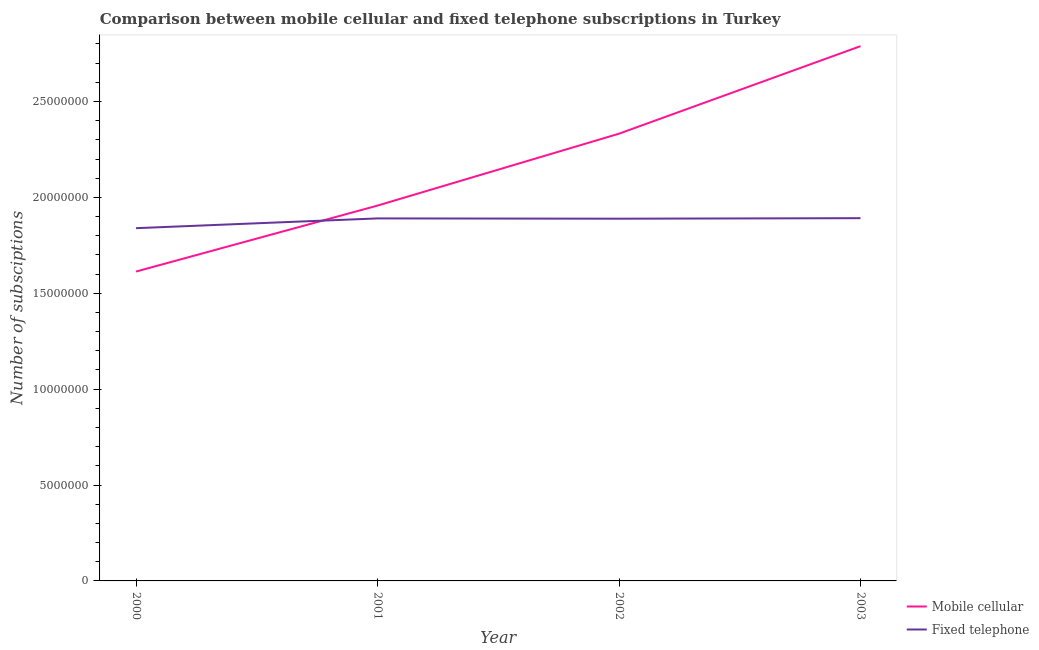How many different coloured lines are there?
Ensure brevity in your answer.  2. Does the line corresponding to number of fixed telephone subscriptions intersect with the line corresponding to number of mobile cellular subscriptions?
Keep it short and to the point. Yes. What is the number of fixed telephone subscriptions in 2000?
Provide a short and direct response. 1.84e+07. Across all years, what is the maximum number of fixed telephone subscriptions?
Keep it short and to the point. 1.89e+07. Across all years, what is the minimum number of mobile cellular subscriptions?
Provide a succinct answer. 1.61e+07. In which year was the number of mobile cellular subscriptions maximum?
Make the answer very short. 2003. In which year was the number of fixed telephone subscriptions minimum?
Provide a succinct answer. 2000. What is the total number of mobile cellular subscriptions in the graph?
Give a very brief answer. 8.69e+07. What is the difference between the number of mobile cellular subscriptions in 2000 and that in 2001?
Provide a succinct answer. -3.44e+06. What is the difference between the number of mobile cellular subscriptions in 2002 and the number of fixed telephone subscriptions in 2001?
Your answer should be very brief. 4.42e+06. What is the average number of fixed telephone subscriptions per year?
Offer a terse response. 1.88e+07. In the year 2000, what is the difference between the number of mobile cellular subscriptions and number of fixed telephone subscriptions?
Keep it short and to the point. -2.26e+06. What is the ratio of the number of mobile cellular subscriptions in 2002 to that in 2003?
Give a very brief answer. 0.84. Is the number of mobile cellular subscriptions in 2000 less than that in 2001?
Your answer should be compact. Yes. What is the difference between the highest and the second highest number of fixed telephone subscriptions?
Your response must be concise. 1.22e+04. What is the difference between the highest and the lowest number of fixed telephone subscriptions?
Offer a terse response. 5.22e+05. Is the sum of the number of mobile cellular subscriptions in 2000 and 2001 greater than the maximum number of fixed telephone subscriptions across all years?
Provide a succinct answer. Yes. How many lines are there?
Make the answer very short. 2. How many years are there in the graph?
Ensure brevity in your answer.  4. Are the values on the major ticks of Y-axis written in scientific E-notation?
Give a very brief answer. No. Does the graph contain any zero values?
Your response must be concise. No. Where does the legend appear in the graph?
Your answer should be very brief. Bottom right. What is the title of the graph?
Your response must be concise. Comparison between mobile cellular and fixed telephone subscriptions in Turkey. Does "Private credit bureau" appear as one of the legend labels in the graph?
Your answer should be very brief. No. What is the label or title of the X-axis?
Your answer should be compact. Year. What is the label or title of the Y-axis?
Your response must be concise. Number of subsciptions. What is the Number of subsciptions of Mobile cellular in 2000?
Your response must be concise. 1.61e+07. What is the Number of subsciptions in Fixed telephone in 2000?
Give a very brief answer. 1.84e+07. What is the Number of subsciptions of Mobile cellular in 2001?
Your response must be concise. 1.96e+07. What is the Number of subsciptions of Fixed telephone in 2001?
Provide a succinct answer. 1.89e+07. What is the Number of subsciptions of Mobile cellular in 2002?
Ensure brevity in your answer.  2.33e+07. What is the Number of subsciptions in Fixed telephone in 2002?
Your answer should be very brief. 1.89e+07. What is the Number of subsciptions of Mobile cellular in 2003?
Provide a short and direct response. 2.79e+07. What is the Number of subsciptions in Fixed telephone in 2003?
Offer a very short reply. 1.89e+07. Across all years, what is the maximum Number of subsciptions in Mobile cellular?
Keep it short and to the point. 2.79e+07. Across all years, what is the maximum Number of subsciptions of Fixed telephone?
Offer a very short reply. 1.89e+07. Across all years, what is the minimum Number of subsciptions of Mobile cellular?
Your answer should be compact. 1.61e+07. Across all years, what is the minimum Number of subsciptions in Fixed telephone?
Ensure brevity in your answer.  1.84e+07. What is the total Number of subsciptions of Mobile cellular in the graph?
Keep it short and to the point. 8.69e+07. What is the total Number of subsciptions in Fixed telephone in the graph?
Offer a very short reply. 7.51e+07. What is the difference between the Number of subsciptions of Mobile cellular in 2000 and that in 2001?
Make the answer very short. -3.44e+06. What is the difference between the Number of subsciptions in Fixed telephone in 2000 and that in 2001?
Your answer should be very brief. -5.09e+05. What is the difference between the Number of subsciptions of Mobile cellular in 2000 and that in 2002?
Your answer should be compact. -7.19e+06. What is the difference between the Number of subsciptions in Fixed telephone in 2000 and that in 2002?
Make the answer very short. -4.95e+05. What is the difference between the Number of subsciptions of Mobile cellular in 2000 and that in 2003?
Provide a short and direct response. -1.18e+07. What is the difference between the Number of subsciptions in Fixed telephone in 2000 and that in 2003?
Provide a succinct answer. -5.22e+05. What is the difference between the Number of subsciptions of Mobile cellular in 2001 and that in 2002?
Your answer should be compact. -3.75e+06. What is the difference between the Number of subsciptions of Fixed telephone in 2001 and that in 2002?
Make the answer very short. 1.45e+04. What is the difference between the Number of subsciptions of Mobile cellular in 2001 and that in 2003?
Your answer should be very brief. -8.31e+06. What is the difference between the Number of subsciptions of Fixed telephone in 2001 and that in 2003?
Give a very brief answer. -1.22e+04. What is the difference between the Number of subsciptions of Mobile cellular in 2002 and that in 2003?
Provide a succinct answer. -4.56e+06. What is the difference between the Number of subsciptions in Fixed telephone in 2002 and that in 2003?
Offer a very short reply. -2.67e+04. What is the difference between the Number of subsciptions in Mobile cellular in 2000 and the Number of subsciptions in Fixed telephone in 2001?
Offer a very short reply. -2.77e+06. What is the difference between the Number of subsciptions in Mobile cellular in 2000 and the Number of subsciptions in Fixed telephone in 2002?
Your answer should be compact. -2.76e+06. What is the difference between the Number of subsciptions of Mobile cellular in 2000 and the Number of subsciptions of Fixed telephone in 2003?
Give a very brief answer. -2.78e+06. What is the difference between the Number of subsciptions in Mobile cellular in 2001 and the Number of subsciptions in Fixed telephone in 2002?
Give a very brief answer. 6.83e+05. What is the difference between the Number of subsciptions in Mobile cellular in 2001 and the Number of subsciptions in Fixed telephone in 2003?
Your answer should be very brief. 6.56e+05. What is the difference between the Number of subsciptions of Mobile cellular in 2002 and the Number of subsciptions of Fixed telephone in 2003?
Give a very brief answer. 4.41e+06. What is the average Number of subsciptions of Mobile cellular per year?
Ensure brevity in your answer.  2.17e+07. What is the average Number of subsciptions of Fixed telephone per year?
Your answer should be very brief. 1.88e+07. In the year 2000, what is the difference between the Number of subsciptions of Mobile cellular and Number of subsciptions of Fixed telephone?
Provide a succinct answer. -2.26e+06. In the year 2001, what is the difference between the Number of subsciptions in Mobile cellular and Number of subsciptions in Fixed telephone?
Your response must be concise. 6.68e+05. In the year 2002, what is the difference between the Number of subsciptions of Mobile cellular and Number of subsciptions of Fixed telephone?
Offer a very short reply. 4.43e+06. In the year 2003, what is the difference between the Number of subsciptions of Mobile cellular and Number of subsciptions of Fixed telephone?
Your answer should be compact. 8.97e+06. What is the ratio of the Number of subsciptions of Mobile cellular in 2000 to that in 2001?
Offer a very short reply. 0.82. What is the ratio of the Number of subsciptions in Fixed telephone in 2000 to that in 2001?
Your answer should be compact. 0.97. What is the ratio of the Number of subsciptions in Mobile cellular in 2000 to that in 2002?
Offer a very short reply. 0.69. What is the ratio of the Number of subsciptions in Fixed telephone in 2000 to that in 2002?
Your response must be concise. 0.97. What is the ratio of the Number of subsciptions of Mobile cellular in 2000 to that in 2003?
Provide a succinct answer. 0.58. What is the ratio of the Number of subsciptions in Fixed telephone in 2000 to that in 2003?
Your answer should be very brief. 0.97. What is the ratio of the Number of subsciptions of Mobile cellular in 2001 to that in 2002?
Offer a very short reply. 0.84. What is the ratio of the Number of subsciptions of Fixed telephone in 2001 to that in 2002?
Your answer should be compact. 1. What is the ratio of the Number of subsciptions in Mobile cellular in 2001 to that in 2003?
Ensure brevity in your answer.  0.7. What is the ratio of the Number of subsciptions in Fixed telephone in 2001 to that in 2003?
Offer a terse response. 1. What is the ratio of the Number of subsciptions in Mobile cellular in 2002 to that in 2003?
Your answer should be compact. 0.84. What is the difference between the highest and the second highest Number of subsciptions of Mobile cellular?
Offer a very short reply. 4.56e+06. What is the difference between the highest and the second highest Number of subsciptions in Fixed telephone?
Provide a short and direct response. 1.22e+04. What is the difference between the highest and the lowest Number of subsciptions of Mobile cellular?
Provide a short and direct response. 1.18e+07. What is the difference between the highest and the lowest Number of subsciptions of Fixed telephone?
Provide a succinct answer. 5.22e+05. 